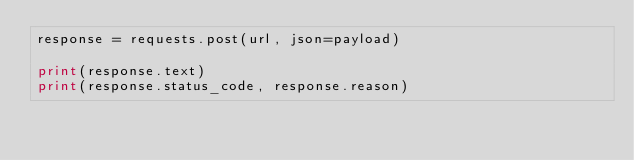Convert code to text. <code><loc_0><loc_0><loc_500><loc_500><_Python_>response = requests.post(url, json=payload)

print(response.text)
print(response.status_code, response.reason)
</code> 